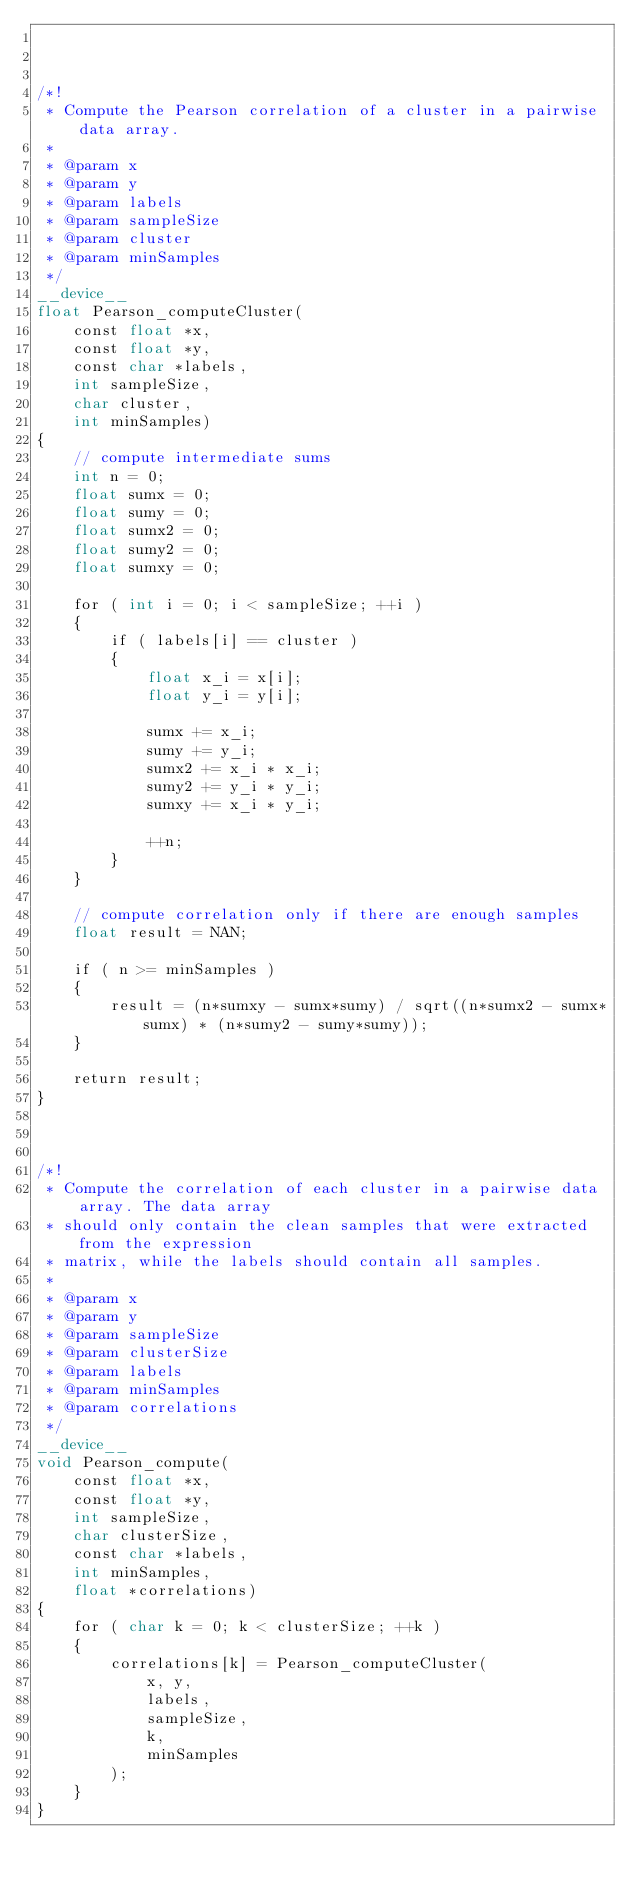Convert code to text. <code><loc_0><loc_0><loc_500><loc_500><_Cuda_>


/*!
 * Compute the Pearson correlation of a cluster in a pairwise data array.
 *
 * @param x
 * @param y
 * @param labels
 * @param sampleSize
 * @param cluster
 * @param minSamples
 */
__device__
float Pearson_computeCluster(
    const float *x,
    const float *y,
    const char *labels,
    int sampleSize,
    char cluster,
    int minSamples)
{
    // compute intermediate sums
    int n = 0;
    float sumx = 0;
    float sumy = 0;
    float sumx2 = 0;
    float sumy2 = 0;
    float sumxy = 0;

    for ( int i = 0; i < sampleSize; ++i )
    {
        if ( labels[i] == cluster )
        {
            float x_i = x[i];
            float y_i = y[i];

            sumx += x_i;
            sumy += y_i;
            sumx2 += x_i * x_i;
            sumy2 += y_i * y_i;
            sumxy += x_i * y_i;

            ++n;
        }
    }

    // compute correlation only if there are enough samples
    float result = NAN;

    if ( n >= minSamples )
    {
        result = (n*sumxy - sumx*sumy) / sqrt((n*sumx2 - sumx*sumx) * (n*sumy2 - sumy*sumy));
    }

    return result;
}



/*!
 * Compute the correlation of each cluster in a pairwise data array. The data array
 * should only contain the clean samples that were extracted from the expression
 * matrix, while the labels should contain all samples.
 *
 * @param x
 * @param y
 * @param sampleSize
 * @param clusterSize
 * @param labels
 * @param minSamples
 * @param correlations
 */
__device__
void Pearson_compute(
    const float *x,
    const float *y,
    int sampleSize,
    char clusterSize,
    const char *labels,
    int minSamples,
    float *correlations)
{
    for ( char k = 0; k < clusterSize; ++k )
    {
        correlations[k] = Pearson_computeCluster(
            x, y,
            labels,
            sampleSize,
            k,
            minSamples
        );
    }
}
</code> 